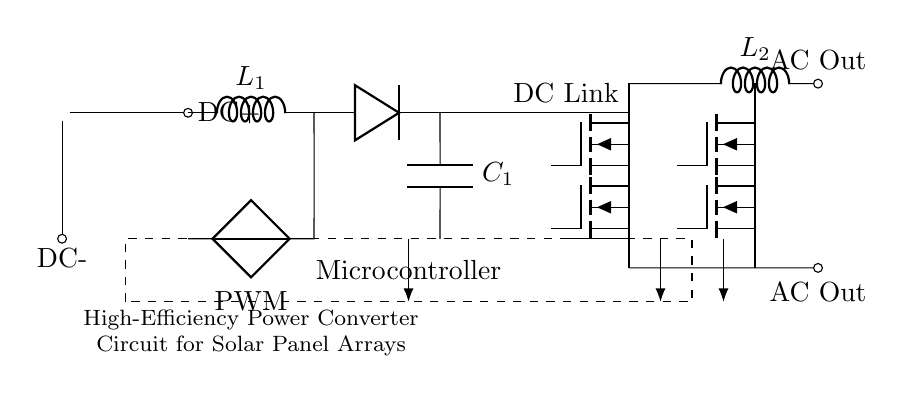What type of converter is shown in this circuit? The circuit features a DC-DC boost converter, which increases the voltage from the solar panel before further processing. This is evident from the inductor (L1) and the diode symbol in the topology, characteristic of boost converters.
Answer: DC-DC boost converter What is the role of the inductor L1? Inductor L1 stores energy during the switching phase of the boost converter and releases it to increase voltage output. This function is integral to the boost converter's operation, as evidenced by its placement and standard usage in such circuits.
Answer: Energy storage How many N-channel MOSFETs are used in this circuit? The circuit includes four N-channel MOSFETs (Q1, Q2, Q3, Q4), which can be identified by their symbols positioned in pairs that facilitate the switching mechanism required by the inverter section.
Answer: Four What component regulates the output voltage? The Microcontroller is responsible for regulating the output voltage by controlling the PWM signal, which is indicated by the connections from the microcontroller to the components that influence the switching behavior in the circuit.
Answer: Microcontroller What is the output of this circuit labeled as? The output of the circuit is labeled as "AC Out," which denotes that the circuit converts the DC power from the solar panel into AC voltage suitable for grid connection or other applications. This labeling is visible in the output section of the diagram.
Answer: AC Out What type of capacitor is shown in the circuit diagram? The circuit features a smoothing capacitor labeled as C1, which serves to filter and smooth the output voltage from the boost converter; its role is commonly associated with DC output smoothing in power electronics.
Answer: Smoothing capacitor 